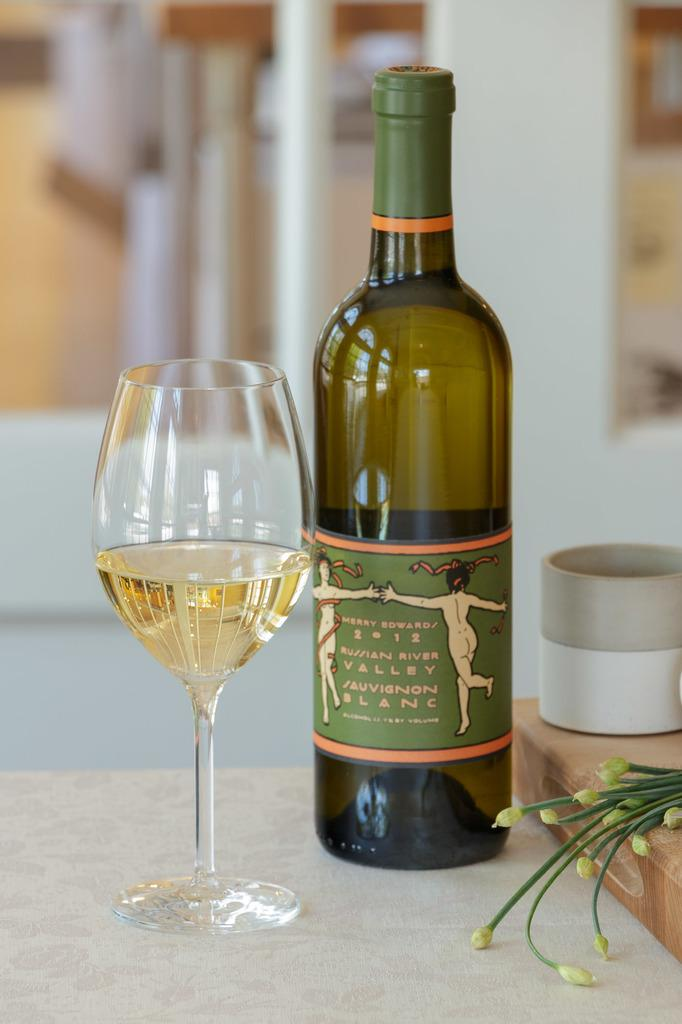Provide a one-sentence caption for the provided image. A wine bottle with the label Mary Edwards 2012 Russian River Valley Sauvignon Blanc  and a filled wine glass beside it. 